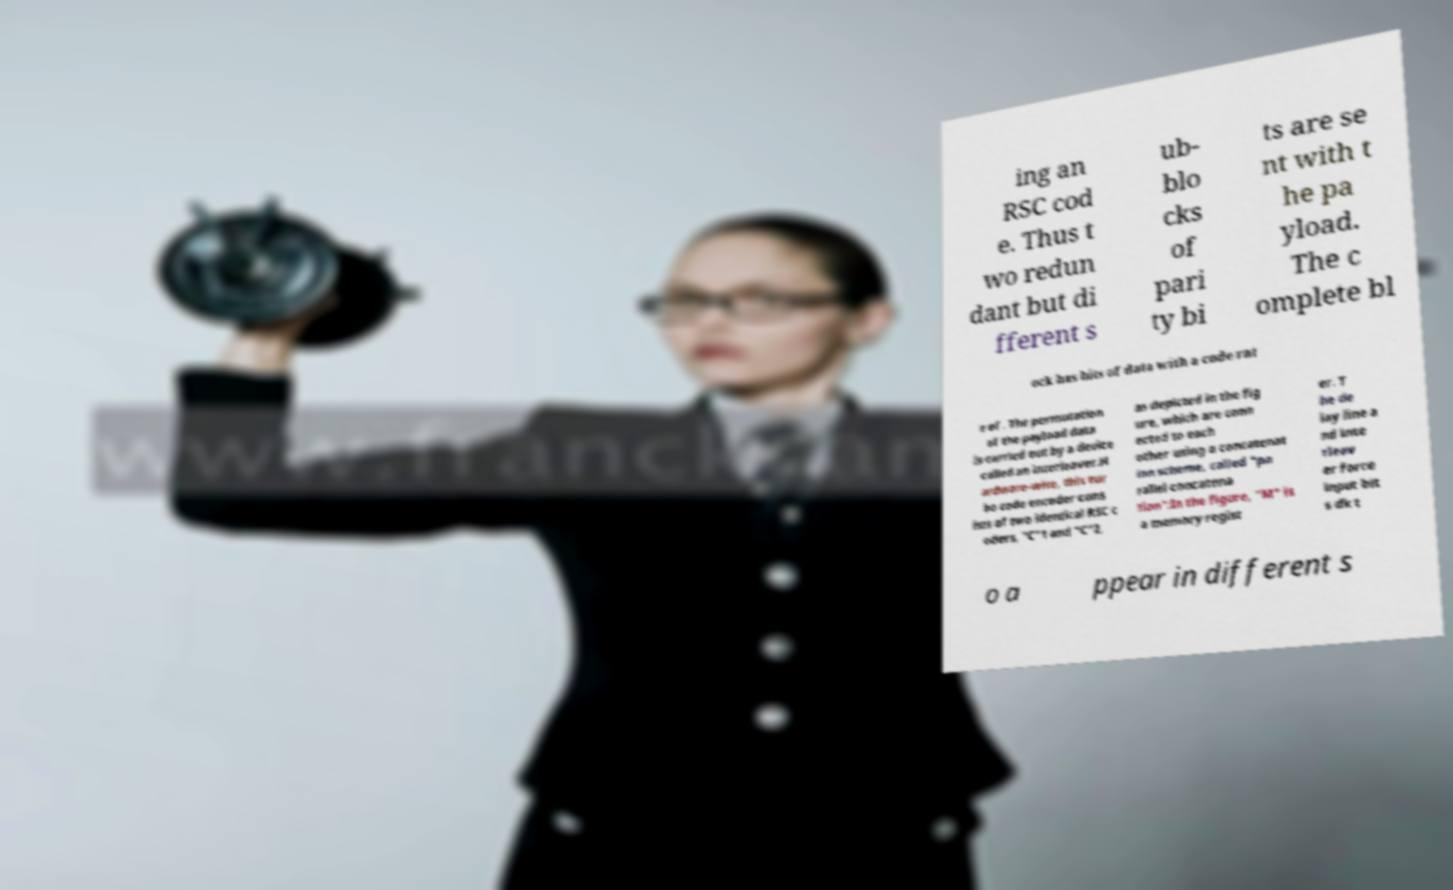Could you extract and type out the text from this image? ing an RSC cod e. Thus t wo redun dant but di fferent s ub- blo cks of pari ty bi ts are se nt with t he pa yload. The c omplete bl ock has bits of data with a code rat e of . The permutation of the payload data is carried out by a device called an interleaver.H ardware-wise, this tur bo code encoder cons ists of two identical RSC c oders, "C"1 and "C"2, as depicted in the fig ure, which are conn ected to each other using a concatenat ion scheme, called "pa rallel concatena tion":In the figure, "M" is a memory regist er. T he de lay line a nd inte rleav er force input bit s dk t o a ppear in different s 